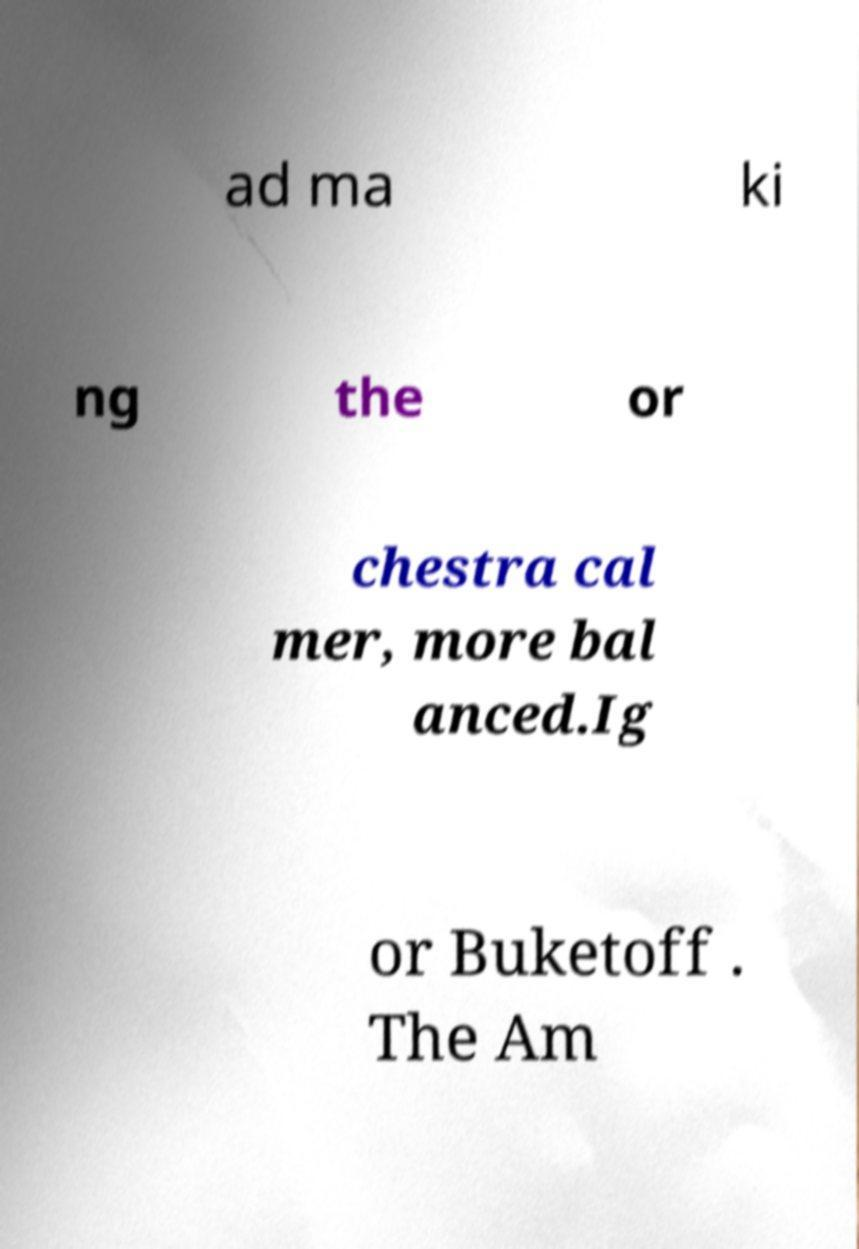Can you accurately transcribe the text from the provided image for me? ad ma ki ng the or chestra cal mer, more bal anced.Ig or Buketoff . The Am 